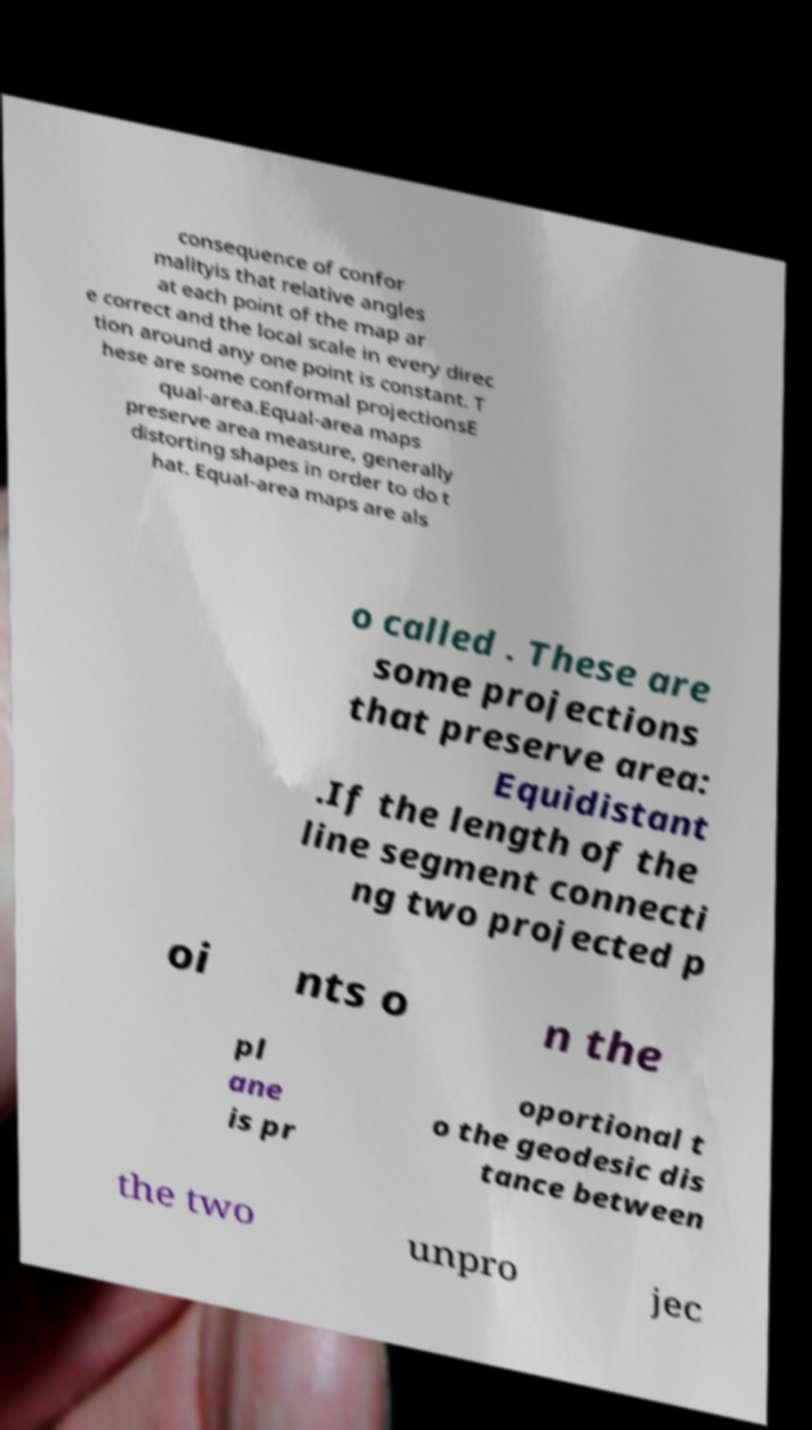Can you accurately transcribe the text from the provided image for me? consequence of confor malityis that relative angles at each point of the map ar e correct and the local scale in every direc tion around any one point is constant. T hese are some conformal projectionsE qual-area.Equal-area maps preserve area measure, generally distorting shapes in order to do t hat. Equal-area maps are als o called . These are some projections that preserve area: Equidistant .If the length of the line segment connecti ng two projected p oi nts o n the pl ane is pr oportional t o the geodesic dis tance between the two unpro jec 